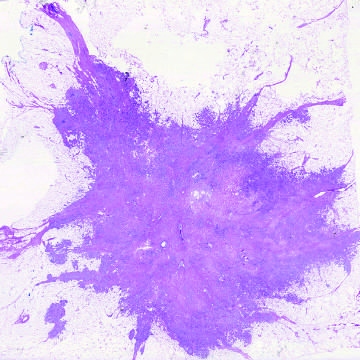does the microscopic view of breast carcinoma illustrate the invasion of breast stroma and fat by nests and cords of tumor cells?
Answer the question using a single word or phrase. Yes 